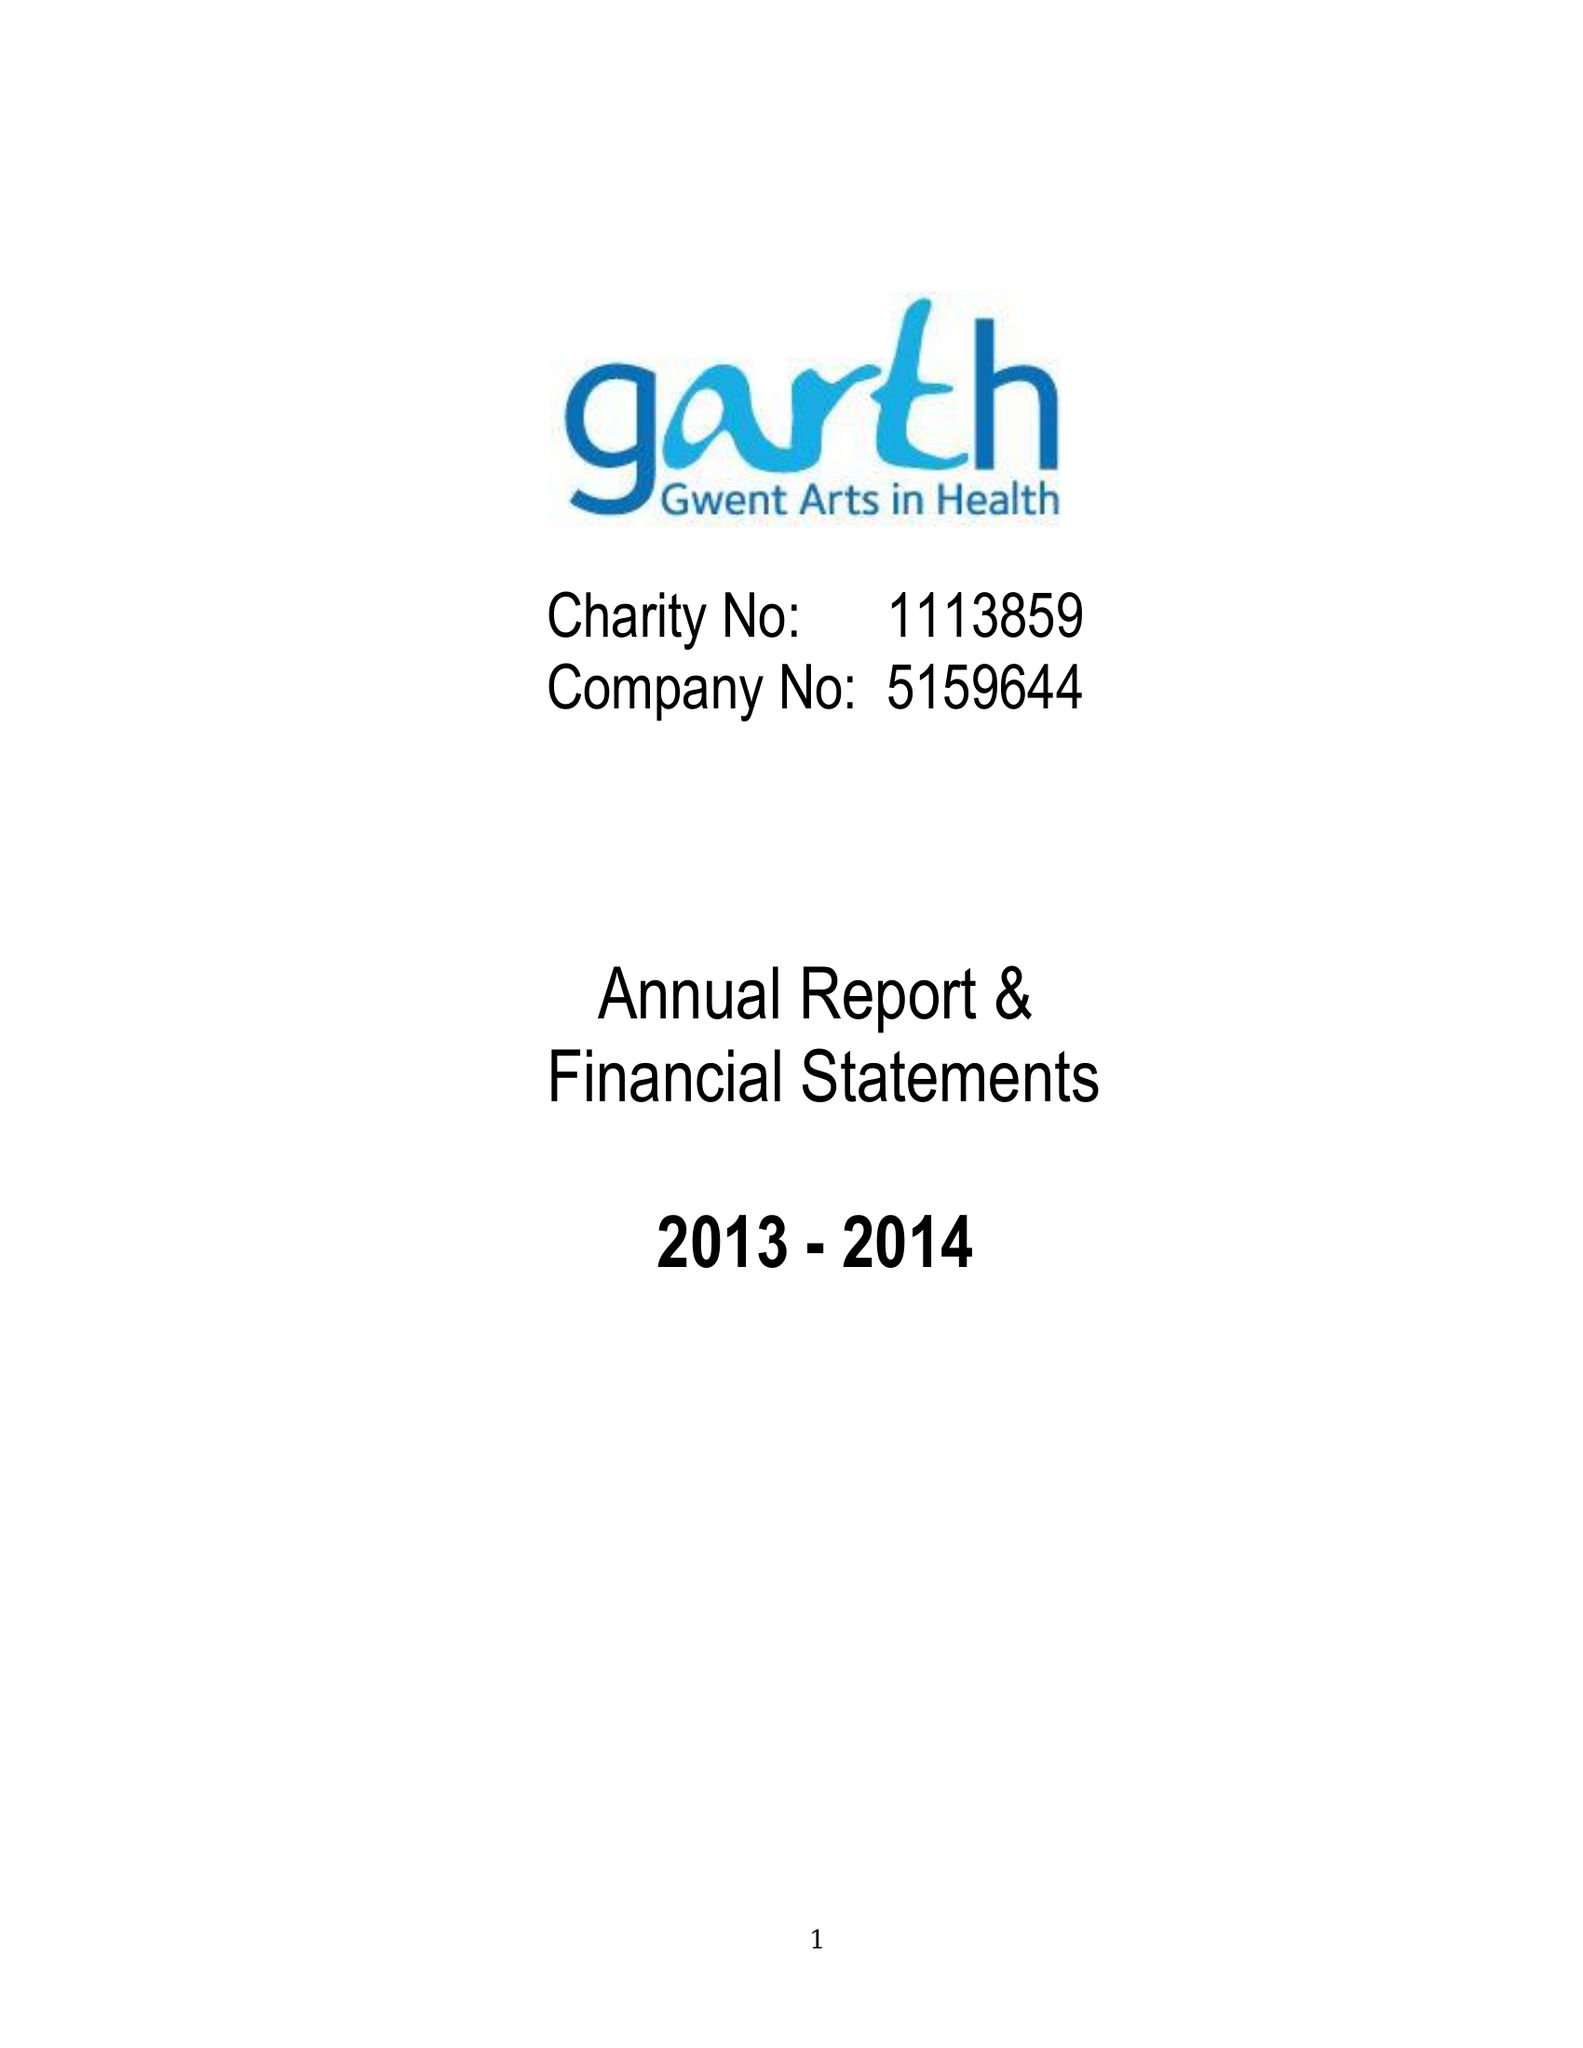What is the value for the charity_name?
Answer the question using a single word or phrase. Gwent Arts In Health (Garth) 